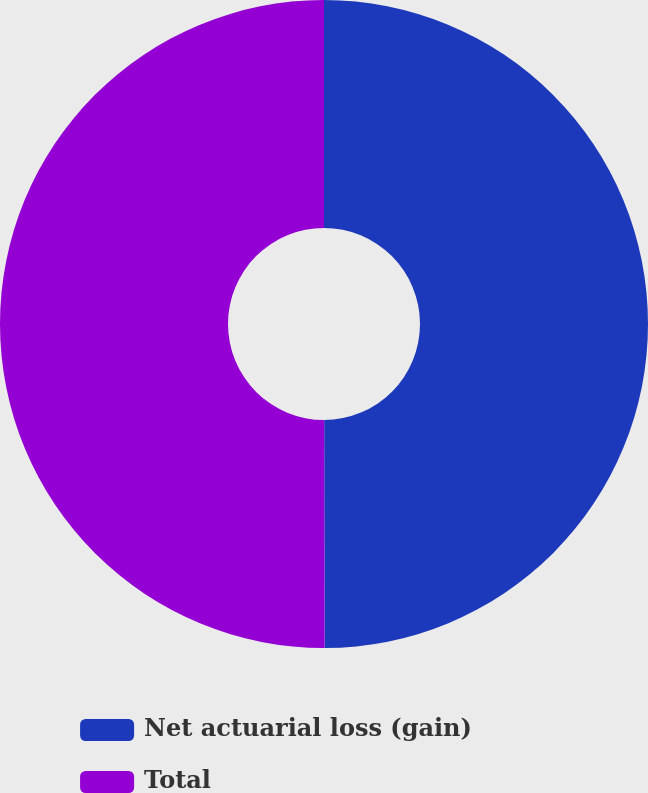<chart> <loc_0><loc_0><loc_500><loc_500><pie_chart><fcel>Net actuarial loss (gain)<fcel>Total<nl><fcel>49.97%<fcel>50.03%<nl></chart> 